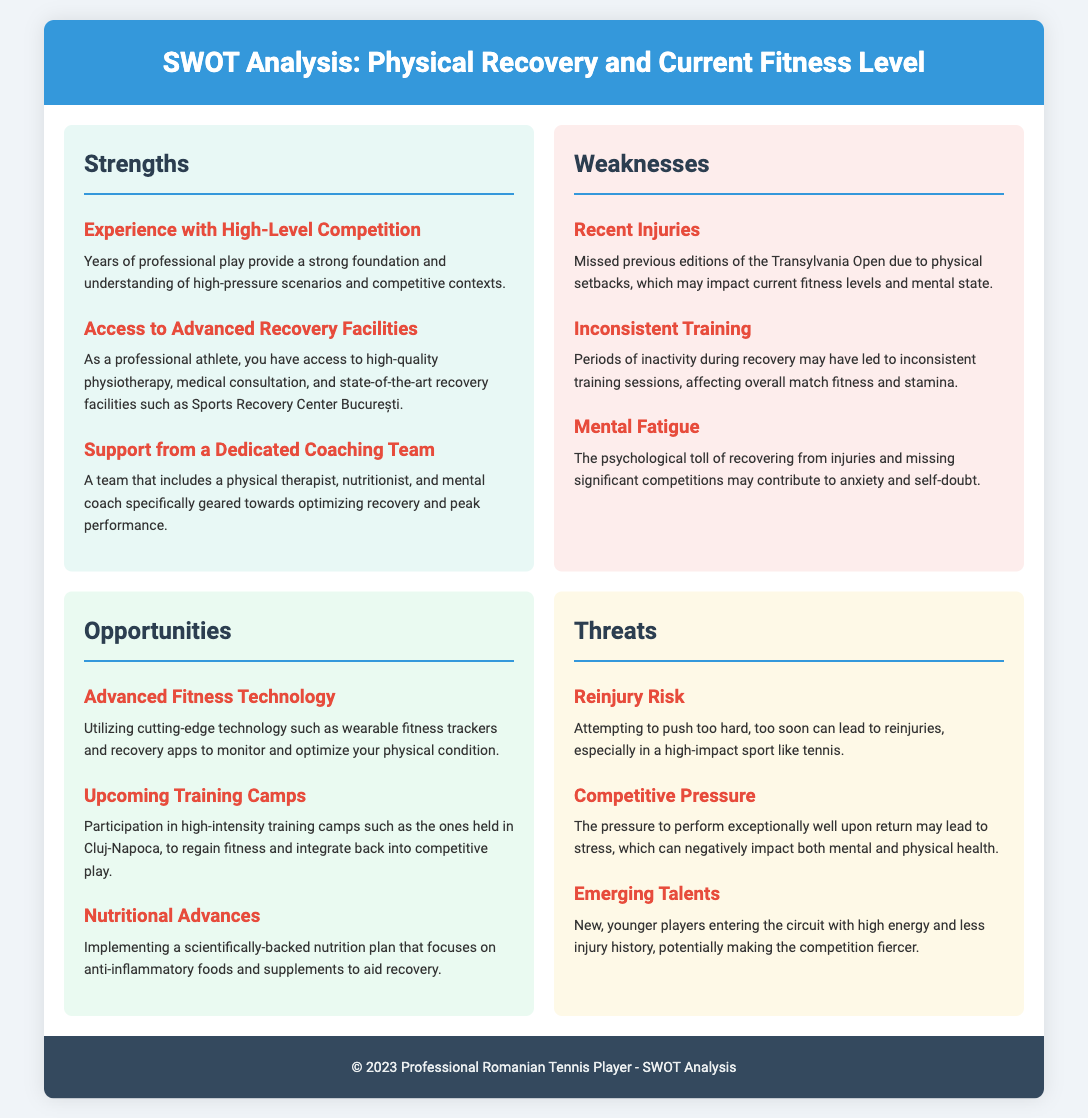What are two strengths? The strengths listed include experience with high-level competition and access to advanced recovery facilities.
Answer: experience with high-level competition, access to advanced recovery facilities What is a weakness related to recent experiences? The document states that recent injuries have caused the athlete to miss previous editions of the Transylvania Open.
Answer: recent injuries What upcoming opportunity involves technology? The opportunity pertaining to technology discusses utilizing advanced fitness technology like wearable fitness trackers.
Answer: advanced fitness technology What is one threat that involves health risks? The threat regarding health risks mentions the risk of reinjury due to pushing too hard.
Answer: reinjury risk Who is part of the dedicated coaching team mentioned in strengths? The document refers to a team that includes a physical therapist, nutritionist, and mental coach.
Answer: physical therapist, nutritionist, mental coach 